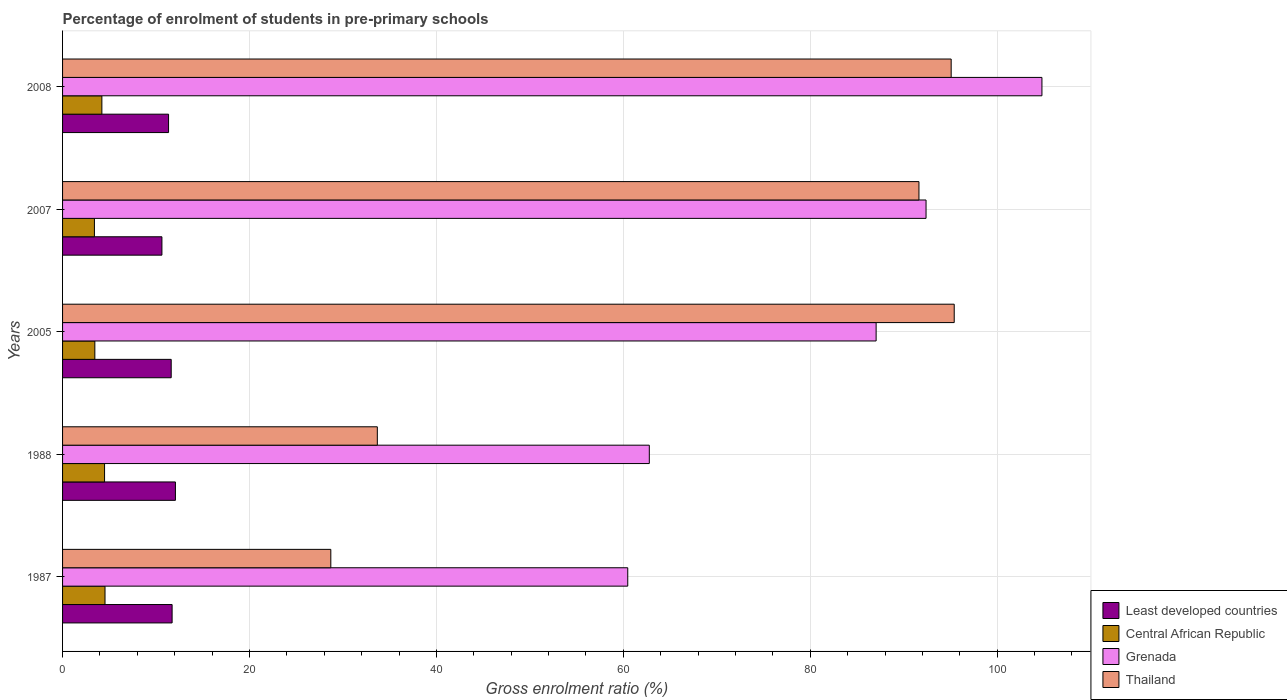How many different coloured bars are there?
Keep it short and to the point. 4. Are the number of bars on each tick of the Y-axis equal?
Offer a very short reply. Yes. How many bars are there on the 5th tick from the top?
Provide a succinct answer. 4. How many bars are there on the 1st tick from the bottom?
Keep it short and to the point. 4. What is the label of the 1st group of bars from the top?
Offer a very short reply. 2008. What is the percentage of students enrolled in pre-primary schools in Thailand in 2007?
Your answer should be compact. 91.63. Across all years, what is the maximum percentage of students enrolled in pre-primary schools in Thailand?
Provide a short and direct response. 95.4. Across all years, what is the minimum percentage of students enrolled in pre-primary schools in Thailand?
Make the answer very short. 28.7. In which year was the percentage of students enrolled in pre-primary schools in Thailand minimum?
Offer a very short reply. 1987. What is the total percentage of students enrolled in pre-primary schools in Thailand in the graph?
Offer a very short reply. 344.48. What is the difference between the percentage of students enrolled in pre-primary schools in Thailand in 1988 and that in 2005?
Offer a terse response. -61.73. What is the difference between the percentage of students enrolled in pre-primary schools in Thailand in 2005 and the percentage of students enrolled in pre-primary schools in Least developed countries in 2007?
Your answer should be very brief. 84.77. What is the average percentage of students enrolled in pre-primary schools in Central African Republic per year?
Your answer should be compact. 4.02. In the year 1987, what is the difference between the percentage of students enrolled in pre-primary schools in Grenada and percentage of students enrolled in pre-primary schools in Least developed countries?
Your answer should be very brief. 48.75. In how many years, is the percentage of students enrolled in pre-primary schools in Thailand greater than 88 %?
Ensure brevity in your answer.  3. What is the ratio of the percentage of students enrolled in pre-primary schools in Central African Republic in 1987 to that in 2005?
Keep it short and to the point. 1.32. Is the difference between the percentage of students enrolled in pre-primary schools in Grenada in 1987 and 2008 greater than the difference between the percentage of students enrolled in pre-primary schools in Least developed countries in 1987 and 2008?
Give a very brief answer. No. What is the difference between the highest and the second highest percentage of students enrolled in pre-primary schools in Central African Republic?
Keep it short and to the point. 0.05. What is the difference between the highest and the lowest percentage of students enrolled in pre-primary schools in Central African Republic?
Keep it short and to the point. 1.13. In how many years, is the percentage of students enrolled in pre-primary schools in Thailand greater than the average percentage of students enrolled in pre-primary schools in Thailand taken over all years?
Your answer should be very brief. 3. What does the 4th bar from the top in 1987 represents?
Provide a short and direct response. Least developed countries. What does the 2nd bar from the bottom in 1987 represents?
Give a very brief answer. Central African Republic. Is it the case that in every year, the sum of the percentage of students enrolled in pre-primary schools in Grenada and percentage of students enrolled in pre-primary schools in Central African Republic is greater than the percentage of students enrolled in pre-primary schools in Thailand?
Offer a terse response. No. What is the difference between two consecutive major ticks on the X-axis?
Your answer should be very brief. 20. Does the graph contain any zero values?
Offer a very short reply. No. How are the legend labels stacked?
Your answer should be compact. Vertical. What is the title of the graph?
Your answer should be very brief. Percentage of enrolment of students in pre-primary schools. Does "Vanuatu" appear as one of the legend labels in the graph?
Offer a very short reply. No. What is the Gross enrolment ratio (%) in Least developed countries in 1987?
Make the answer very short. 11.72. What is the Gross enrolment ratio (%) of Central African Republic in 1987?
Offer a terse response. 4.54. What is the Gross enrolment ratio (%) in Grenada in 1987?
Provide a succinct answer. 60.47. What is the Gross enrolment ratio (%) of Thailand in 1987?
Provide a short and direct response. 28.7. What is the Gross enrolment ratio (%) in Least developed countries in 1988?
Offer a terse response. 12.08. What is the Gross enrolment ratio (%) of Central African Republic in 1988?
Your response must be concise. 4.49. What is the Gross enrolment ratio (%) in Grenada in 1988?
Your response must be concise. 62.78. What is the Gross enrolment ratio (%) of Thailand in 1988?
Provide a short and direct response. 33.68. What is the Gross enrolment ratio (%) in Least developed countries in 2005?
Offer a terse response. 11.62. What is the Gross enrolment ratio (%) in Central African Republic in 2005?
Your response must be concise. 3.45. What is the Gross enrolment ratio (%) of Grenada in 2005?
Give a very brief answer. 87.05. What is the Gross enrolment ratio (%) of Thailand in 2005?
Offer a very short reply. 95.4. What is the Gross enrolment ratio (%) in Least developed countries in 2007?
Make the answer very short. 10.63. What is the Gross enrolment ratio (%) in Central African Republic in 2007?
Provide a succinct answer. 3.41. What is the Gross enrolment ratio (%) in Grenada in 2007?
Provide a short and direct response. 92.39. What is the Gross enrolment ratio (%) in Thailand in 2007?
Provide a succinct answer. 91.63. What is the Gross enrolment ratio (%) of Least developed countries in 2008?
Keep it short and to the point. 11.34. What is the Gross enrolment ratio (%) of Central African Republic in 2008?
Provide a short and direct response. 4.21. What is the Gross enrolment ratio (%) in Grenada in 2008?
Keep it short and to the point. 104.79. What is the Gross enrolment ratio (%) in Thailand in 2008?
Your answer should be very brief. 95.08. Across all years, what is the maximum Gross enrolment ratio (%) of Least developed countries?
Provide a short and direct response. 12.08. Across all years, what is the maximum Gross enrolment ratio (%) in Central African Republic?
Keep it short and to the point. 4.54. Across all years, what is the maximum Gross enrolment ratio (%) of Grenada?
Provide a succinct answer. 104.79. Across all years, what is the maximum Gross enrolment ratio (%) of Thailand?
Keep it short and to the point. 95.4. Across all years, what is the minimum Gross enrolment ratio (%) in Least developed countries?
Your response must be concise. 10.63. Across all years, what is the minimum Gross enrolment ratio (%) in Central African Republic?
Your answer should be very brief. 3.41. Across all years, what is the minimum Gross enrolment ratio (%) of Grenada?
Keep it short and to the point. 60.47. Across all years, what is the minimum Gross enrolment ratio (%) of Thailand?
Provide a succinct answer. 28.7. What is the total Gross enrolment ratio (%) in Least developed countries in the graph?
Provide a short and direct response. 57.39. What is the total Gross enrolment ratio (%) of Central African Republic in the graph?
Keep it short and to the point. 20.1. What is the total Gross enrolment ratio (%) of Grenada in the graph?
Your answer should be compact. 407.47. What is the total Gross enrolment ratio (%) in Thailand in the graph?
Provide a short and direct response. 344.48. What is the difference between the Gross enrolment ratio (%) of Least developed countries in 1987 and that in 1988?
Your response must be concise. -0.35. What is the difference between the Gross enrolment ratio (%) in Central African Republic in 1987 and that in 1988?
Your response must be concise. 0.05. What is the difference between the Gross enrolment ratio (%) of Grenada in 1987 and that in 1988?
Give a very brief answer. -2.31. What is the difference between the Gross enrolment ratio (%) of Thailand in 1987 and that in 1988?
Offer a terse response. -4.98. What is the difference between the Gross enrolment ratio (%) of Least developed countries in 1987 and that in 2005?
Give a very brief answer. 0.1. What is the difference between the Gross enrolment ratio (%) in Central African Republic in 1987 and that in 2005?
Offer a very short reply. 1.09. What is the difference between the Gross enrolment ratio (%) in Grenada in 1987 and that in 2005?
Provide a short and direct response. -26.57. What is the difference between the Gross enrolment ratio (%) of Thailand in 1987 and that in 2005?
Offer a very short reply. -66.7. What is the difference between the Gross enrolment ratio (%) in Least developed countries in 1987 and that in 2007?
Your response must be concise. 1.09. What is the difference between the Gross enrolment ratio (%) of Central African Republic in 1987 and that in 2007?
Keep it short and to the point. 1.13. What is the difference between the Gross enrolment ratio (%) in Grenada in 1987 and that in 2007?
Provide a succinct answer. -31.92. What is the difference between the Gross enrolment ratio (%) in Thailand in 1987 and that in 2007?
Your response must be concise. -62.93. What is the difference between the Gross enrolment ratio (%) of Least developed countries in 1987 and that in 2008?
Make the answer very short. 0.38. What is the difference between the Gross enrolment ratio (%) in Central African Republic in 1987 and that in 2008?
Ensure brevity in your answer.  0.34. What is the difference between the Gross enrolment ratio (%) of Grenada in 1987 and that in 2008?
Provide a succinct answer. -44.32. What is the difference between the Gross enrolment ratio (%) of Thailand in 1987 and that in 2008?
Make the answer very short. -66.38. What is the difference between the Gross enrolment ratio (%) of Least developed countries in 1988 and that in 2005?
Offer a terse response. 0.45. What is the difference between the Gross enrolment ratio (%) in Central African Republic in 1988 and that in 2005?
Your answer should be very brief. 1.04. What is the difference between the Gross enrolment ratio (%) in Grenada in 1988 and that in 2005?
Your response must be concise. -24.27. What is the difference between the Gross enrolment ratio (%) in Thailand in 1988 and that in 2005?
Your answer should be very brief. -61.73. What is the difference between the Gross enrolment ratio (%) of Least developed countries in 1988 and that in 2007?
Offer a terse response. 1.45. What is the difference between the Gross enrolment ratio (%) of Central African Republic in 1988 and that in 2007?
Give a very brief answer. 1.09. What is the difference between the Gross enrolment ratio (%) of Grenada in 1988 and that in 2007?
Provide a short and direct response. -29.61. What is the difference between the Gross enrolment ratio (%) in Thailand in 1988 and that in 2007?
Your response must be concise. -57.95. What is the difference between the Gross enrolment ratio (%) in Least developed countries in 1988 and that in 2008?
Keep it short and to the point. 0.73. What is the difference between the Gross enrolment ratio (%) in Central African Republic in 1988 and that in 2008?
Your answer should be compact. 0.29. What is the difference between the Gross enrolment ratio (%) of Grenada in 1988 and that in 2008?
Provide a short and direct response. -42.01. What is the difference between the Gross enrolment ratio (%) of Thailand in 1988 and that in 2008?
Give a very brief answer. -61.4. What is the difference between the Gross enrolment ratio (%) of Central African Republic in 2005 and that in 2007?
Offer a very short reply. 0.05. What is the difference between the Gross enrolment ratio (%) in Grenada in 2005 and that in 2007?
Your response must be concise. -5.34. What is the difference between the Gross enrolment ratio (%) of Thailand in 2005 and that in 2007?
Your answer should be compact. 3.77. What is the difference between the Gross enrolment ratio (%) of Least developed countries in 2005 and that in 2008?
Ensure brevity in your answer.  0.28. What is the difference between the Gross enrolment ratio (%) in Central African Republic in 2005 and that in 2008?
Provide a succinct answer. -0.75. What is the difference between the Gross enrolment ratio (%) of Grenada in 2005 and that in 2008?
Offer a terse response. -17.74. What is the difference between the Gross enrolment ratio (%) of Thailand in 2005 and that in 2008?
Ensure brevity in your answer.  0.33. What is the difference between the Gross enrolment ratio (%) in Least developed countries in 2007 and that in 2008?
Give a very brief answer. -0.71. What is the difference between the Gross enrolment ratio (%) in Central African Republic in 2007 and that in 2008?
Your answer should be compact. -0.8. What is the difference between the Gross enrolment ratio (%) of Grenada in 2007 and that in 2008?
Keep it short and to the point. -12.4. What is the difference between the Gross enrolment ratio (%) in Thailand in 2007 and that in 2008?
Offer a terse response. -3.45. What is the difference between the Gross enrolment ratio (%) in Least developed countries in 1987 and the Gross enrolment ratio (%) in Central African Republic in 1988?
Give a very brief answer. 7.23. What is the difference between the Gross enrolment ratio (%) of Least developed countries in 1987 and the Gross enrolment ratio (%) of Grenada in 1988?
Offer a very short reply. -51.06. What is the difference between the Gross enrolment ratio (%) of Least developed countries in 1987 and the Gross enrolment ratio (%) of Thailand in 1988?
Your response must be concise. -21.96. What is the difference between the Gross enrolment ratio (%) of Central African Republic in 1987 and the Gross enrolment ratio (%) of Grenada in 1988?
Ensure brevity in your answer.  -58.24. What is the difference between the Gross enrolment ratio (%) of Central African Republic in 1987 and the Gross enrolment ratio (%) of Thailand in 1988?
Make the answer very short. -29.13. What is the difference between the Gross enrolment ratio (%) of Grenada in 1987 and the Gross enrolment ratio (%) of Thailand in 1988?
Offer a terse response. 26.79. What is the difference between the Gross enrolment ratio (%) in Least developed countries in 1987 and the Gross enrolment ratio (%) in Central African Republic in 2005?
Give a very brief answer. 8.27. What is the difference between the Gross enrolment ratio (%) in Least developed countries in 1987 and the Gross enrolment ratio (%) in Grenada in 2005?
Your response must be concise. -75.32. What is the difference between the Gross enrolment ratio (%) in Least developed countries in 1987 and the Gross enrolment ratio (%) in Thailand in 2005?
Provide a short and direct response. -83.68. What is the difference between the Gross enrolment ratio (%) in Central African Republic in 1987 and the Gross enrolment ratio (%) in Grenada in 2005?
Ensure brevity in your answer.  -82.5. What is the difference between the Gross enrolment ratio (%) of Central African Republic in 1987 and the Gross enrolment ratio (%) of Thailand in 2005?
Offer a very short reply. -90.86. What is the difference between the Gross enrolment ratio (%) in Grenada in 1987 and the Gross enrolment ratio (%) in Thailand in 2005?
Offer a very short reply. -34.93. What is the difference between the Gross enrolment ratio (%) in Least developed countries in 1987 and the Gross enrolment ratio (%) in Central African Republic in 2007?
Give a very brief answer. 8.31. What is the difference between the Gross enrolment ratio (%) of Least developed countries in 1987 and the Gross enrolment ratio (%) of Grenada in 2007?
Make the answer very short. -80.67. What is the difference between the Gross enrolment ratio (%) in Least developed countries in 1987 and the Gross enrolment ratio (%) in Thailand in 2007?
Offer a terse response. -79.91. What is the difference between the Gross enrolment ratio (%) of Central African Republic in 1987 and the Gross enrolment ratio (%) of Grenada in 2007?
Give a very brief answer. -87.85. What is the difference between the Gross enrolment ratio (%) of Central African Republic in 1987 and the Gross enrolment ratio (%) of Thailand in 2007?
Ensure brevity in your answer.  -87.09. What is the difference between the Gross enrolment ratio (%) in Grenada in 1987 and the Gross enrolment ratio (%) in Thailand in 2007?
Give a very brief answer. -31.16. What is the difference between the Gross enrolment ratio (%) in Least developed countries in 1987 and the Gross enrolment ratio (%) in Central African Republic in 2008?
Your answer should be very brief. 7.52. What is the difference between the Gross enrolment ratio (%) in Least developed countries in 1987 and the Gross enrolment ratio (%) in Grenada in 2008?
Your answer should be compact. -93.07. What is the difference between the Gross enrolment ratio (%) of Least developed countries in 1987 and the Gross enrolment ratio (%) of Thailand in 2008?
Provide a succinct answer. -83.35. What is the difference between the Gross enrolment ratio (%) of Central African Republic in 1987 and the Gross enrolment ratio (%) of Grenada in 2008?
Offer a very short reply. -100.25. What is the difference between the Gross enrolment ratio (%) in Central African Republic in 1987 and the Gross enrolment ratio (%) in Thailand in 2008?
Ensure brevity in your answer.  -90.53. What is the difference between the Gross enrolment ratio (%) of Grenada in 1987 and the Gross enrolment ratio (%) of Thailand in 2008?
Your answer should be compact. -34.6. What is the difference between the Gross enrolment ratio (%) in Least developed countries in 1988 and the Gross enrolment ratio (%) in Central African Republic in 2005?
Give a very brief answer. 8.62. What is the difference between the Gross enrolment ratio (%) in Least developed countries in 1988 and the Gross enrolment ratio (%) in Grenada in 2005?
Provide a succinct answer. -74.97. What is the difference between the Gross enrolment ratio (%) in Least developed countries in 1988 and the Gross enrolment ratio (%) in Thailand in 2005?
Make the answer very short. -83.33. What is the difference between the Gross enrolment ratio (%) of Central African Republic in 1988 and the Gross enrolment ratio (%) of Grenada in 2005?
Your answer should be very brief. -82.55. What is the difference between the Gross enrolment ratio (%) of Central African Republic in 1988 and the Gross enrolment ratio (%) of Thailand in 2005?
Keep it short and to the point. -90.91. What is the difference between the Gross enrolment ratio (%) in Grenada in 1988 and the Gross enrolment ratio (%) in Thailand in 2005?
Keep it short and to the point. -32.62. What is the difference between the Gross enrolment ratio (%) of Least developed countries in 1988 and the Gross enrolment ratio (%) of Central African Republic in 2007?
Make the answer very short. 8.67. What is the difference between the Gross enrolment ratio (%) of Least developed countries in 1988 and the Gross enrolment ratio (%) of Grenada in 2007?
Give a very brief answer. -80.31. What is the difference between the Gross enrolment ratio (%) of Least developed countries in 1988 and the Gross enrolment ratio (%) of Thailand in 2007?
Make the answer very short. -79.55. What is the difference between the Gross enrolment ratio (%) of Central African Republic in 1988 and the Gross enrolment ratio (%) of Grenada in 2007?
Offer a very short reply. -87.89. What is the difference between the Gross enrolment ratio (%) of Central African Republic in 1988 and the Gross enrolment ratio (%) of Thailand in 2007?
Make the answer very short. -87.13. What is the difference between the Gross enrolment ratio (%) of Grenada in 1988 and the Gross enrolment ratio (%) of Thailand in 2007?
Give a very brief answer. -28.85. What is the difference between the Gross enrolment ratio (%) in Least developed countries in 1988 and the Gross enrolment ratio (%) in Central African Republic in 2008?
Ensure brevity in your answer.  7.87. What is the difference between the Gross enrolment ratio (%) in Least developed countries in 1988 and the Gross enrolment ratio (%) in Grenada in 2008?
Make the answer very short. -92.71. What is the difference between the Gross enrolment ratio (%) of Least developed countries in 1988 and the Gross enrolment ratio (%) of Thailand in 2008?
Offer a terse response. -83. What is the difference between the Gross enrolment ratio (%) of Central African Republic in 1988 and the Gross enrolment ratio (%) of Grenada in 2008?
Your answer should be very brief. -100.29. What is the difference between the Gross enrolment ratio (%) of Central African Republic in 1988 and the Gross enrolment ratio (%) of Thailand in 2008?
Give a very brief answer. -90.58. What is the difference between the Gross enrolment ratio (%) of Grenada in 1988 and the Gross enrolment ratio (%) of Thailand in 2008?
Make the answer very short. -32.3. What is the difference between the Gross enrolment ratio (%) in Least developed countries in 2005 and the Gross enrolment ratio (%) in Central African Republic in 2007?
Keep it short and to the point. 8.21. What is the difference between the Gross enrolment ratio (%) of Least developed countries in 2005 and the Gross enrolment ratio (%) of Grenada in 2007?
Your response must be concise. -80.77. What is the difference between the Gross enrolment ratio (%) of Least developed countries in 2005 and the Gross enrolment ratio (%) of Thailand in 2007?
Offer a very short reply. -80.01. What is the difference between the Gross enrolment ratio (%) in Central African Republic in 2005 and the Gross enrolment ratio (%) in Grenada in 2007?
Your response must be concise. -88.93. What is the difference between the Gross enrolment ratio (%) of Central African Republic in 2005 and the Gross enrolment ratio (%) of Thailand in 2007?
Offer a very short reply. -88.17. What is the difference between the Gross enrolment ratio (%) of Grenada in 2005 and the Gross enrolment ratio (%) of Thailand in 2007?
Offer a very short reply. -4.58. What is the difference between the Gross enrolment ratio (%) in Least developed countries in 2005 and the Gross enrolment ratio (%) in Central African Republic in 2008?
Provide a succinct answer. 7.42. What is the difference between the Gross enrolment ratio (%) of Least developed countries in 2005 and the Gross enrolment ratio (%) of Grenada in 2008?
Your response must be concise. -93.17. What is the difference between the Gross enrolment ratio (%) of Least developed countries in 2005 and the Gross enrolment ratio (%) of Thailand in 2008?
Give a very brief answer. -83.45. What is the difference between the Gross enrolment ratio (%) in Central African Republic in 2005 and the Gross enrolment ratio (%) in Grenada in 2008?
Provide a short and direct response. -101.33. What is the difference between the Gross enrolment ratio (%) in Central African Republic in 2005 and the Gross enrolment ratio (%) in Thailand in 2008?
Your response must be concise. -91.62. What is the difference between the Gross enrolment ratio (%) in Grenada in 2005 and the Gross enrolment ratio (%) in Thailand in 2008?
Your response must be concise. -8.03. What is the difference between the Gross enrolment ratio (%) in Least developed countries in 2007 and the Gross enrolment ratio (%) in Central African Republic in 2008?
Your response must be concise. 6.42. What is the difference between the Gross enrolment ratio (%) of Least developed countries in 2007 and the Gross enrolment ratio (%) of Grenada in 2008?
Provide a short and direct response. -94.16. What is the difference between the Gross enrolment ratio (%) in Least developed countries in 2007 and the Gross enrolment ratio (%) in Thailand in 2008?
Keep it short and to the point. -84.45. What is the difference between the Gross enrolment ratio (%) of Central African Republic in 2007 and the Gross enrolment ratio (%) of Grenada in 2008?
Your response must be concise. -101.38. What is the difference between the Gross enrolment ratio (%) of Central African Republic in 2007 and the Gross enrolment ratio (%) of Thailand in 2008?
Your answer should be compact. -91.67. What is the difference between the Gross enrolment ratio (%) of Grenada in 2007 and the Gross enrolment ratio (%) of Thailand in 2008?
Your answer should be very brief. -2.69. What is the average Gross enrolment ratio (%) in Least developed countries per year?
Keep it short and to the point. 11.48. What is the average Gross enrolment ratio (%) in Central African Republic per year?
Give a very brief answer. 4.02. What is the average Gross enrolment ratio (%) of Grenada per year?
Make the answer very short. 81.49. What is the average Gross enrolment ratio (%) of Thailand per year?
Offer a terse response. 68.9. In the year 1987, what is the difference between the Gross enrolment ratio (%) in Least developed countries and Gross enrolment ratio (%) in Central African Republic?
Offer a terse response. 7.18. In the year 1987, what is the difference between the Gross enrolment ratio (%) of Least developed countries and Gross enrolment ratio (%) of Grenada?
Offer a very short reply. -48.75. In the year 1987, what is the difference between the Gross enrolment ratio (%) in Least developed countries and Gross enrolment ratio (%) in Thailand?
Provide a short and direct response. -16.98. In the year 1987, what is the difference between the Gross enrolment ratio (%) of Central African Republic and Gross enrolment ratio (%) of Grenada?
Give a very brief answer. -55.93. In the year 1987, what is the difference between the Gross enrolment ratio (%) in Central African Republic and Gross enrolment ratio (%) in Thailand?
Make the answer very short. -24.16. In the year 1987, what is the difference between the Gross enrolment ratio (%) of Grenada and Gross enrolment ratio (%) of Thailand?
Provide a short and direct response. 31.77. In the year 1988, what is the difference between the Gross enrolment ratio (%) of Least developed countries and Gross enrolment ratio (%) of Central African Republic?
Your answer should be very brief. 7.58. In the year 1988, what is the difference between the Gross enrolment ratio (%) in Least developed countries and Gross enrolment ratio (%) in Grenada?
Provide a short and direct response. -50.7. In the year 1988, what is the difference between the Gross enrolment ratio (%) of Least developed countries and Gross enrolment ratio (%) of Thailand?
Your response must be concise. -21.6. In the year 1988, what is the difference between the Gross enrolment ratio (%) in Central African Republic and Gross enrolment ratio (%) in Grenada?
Your answer should be compact. -58.28. In the year 1988, what is the difference between the Gross enrolment ratio (%) of Central African Republic and Gross enrolment ratio (%) of Thailand?
Provide a short and direct response. -29.18. In the year 1988, what is the difference between the Gross enrolment ratio (%) of Grenada and Gross enrolment ratio (%) of Thailand?
Keep it short and to the point. 29.1. In the year 2005, what is the difference between the Gross enrolment ratio (%) in Least developed countries and Gross enrolment ratio (%) in Central African Republic?
Your answer should be very brief. 8.17. In the year 2005, what is the difference between the Gross enrolment ratio (%) in Least developed countries and Gross enrolment ratio (%) in Grenada?
Ensure brevity in your answer.  -75.42. In the year 2005, what is the difference between the Gross enrolment ratio (%) of Least developed countries and Gross enrolment ratio (%) of Thailand?
Make the answer very short. -83.78. In the year 2005, what is the difference between the Gross enrolment ratio (%) of Central African Republic and Gross enrolment ratio (%) of Grenada?
Give a very brief answer. -83.59. In the year 2005, what is the difference between the Gross enrolment ratio (%) of Central African Republic and Gross enrolment ratio (%) of Thailand?
Provide a short and direct response. -91.95. In the year 2005, what is the difference between the Gross enrolment ratio (%) in Grenada and Gross enrolment ratio (%) in Thailand?
Keep it short and to the point. -8.36. In the year 2007, what is the difference between the Gross enrolment ratio (%) of Least developed countries and Gross enrolment ratio (%) of Central African Republic?
Offer a terse response. 7.22. In the year 2007, what is the difference between the Gross enrolment ratio (%) in Least developed countries and Gross enrolment ratio (%) in Grenada?
Make the answer very short. -81.76. In the year 2007, what is the difference between the Gross enrolment ratio (%) of Least developed countries and Gross enrolment ratio (%) of Thailand?
Your response must be concise. -81. In the year 2007, what is the difference between the Gross enrolment ratio (%) of Central African Republic and Gross enrolment ratio (%) of Grenada?
Keep it short and to the point. -88.98. In the year 2007, what is the difference between the Gross enrolment ratio (%) of Central African Republic and Gross enrolment ratio (%) of Thailand?
Offer a very short reply. -88.22. In the year 2007, what is the difference between the Gross enrolment ratio (%) in Grenada and Gross enrolment ratio (%) in Thailand?
Offer a terse response. 0.76. In the year 2008, what is the difference between the Gross enrolment ratio (%) in Least developed countries and Gross enrolment ratio (%) in Central African Republic?
Make the answer very short. 7.14. In the year 2008, what is the difference between the Gross enrolment ratio (%) of Least developed countries and Gross enrolment ratio (%) of Grenada?
Keep it short and to the point. -93.45. In the year 2008, what is the difference between the Gross enrolment ratio (%) in Least developed countries and Gross enrolment ratio (%) in Thailand?
Your response must be concise. -83.73. In the year 2008, what is the difference between the Gross enrolment ratio (%) in Central African Republic and Gross enrolment ratio (%) in Grenada?
Make the answer very short. -100.58. In the year 2008, what is the difference between the Gross enrolment ratio (%) in Central African Republic and Gross enrolment ratio (%) in Thailand?
Your response must be concise. -90.87. In the year 2008, what is the difference between the Gross enrolment ratio (%) of Grenada and Gross enrolment ratio (%) of Thailand?
Give a very brief answer. 9.71. What is the ratio of the Gross enrolment ratio (%) of Least developed countries in 1987 to that in 1988?
Provide a succinct answer. 0.97. What is the ratio of the Gross enrolment ratio (%) of Central African Republic in 1987 to that in 1988?
Your response must be concise. 1.01. What is the ratio of the Gross enrolment ratio (%) in Grenada in 1987 to that in 1988?
Offer a very short reply. 0.96. What is the ratio of the Gross enrolment ratio (%) of Thailand in 1987 to that in 1988?
Offer a terse response. 0.85. What is the ratio of the Gross enrolment ratio (%) in Least developed countries in 1987 to that in 2005?
Your response must be concise. 1.01. What is the ratio of the Gross enrolment ratio (%) in Central African Republic in 1987 to that in 2005?
Make the answer very short. 1.32. What is the ratio of the Gross enrolment ratio (%) in Grenada in 1987 to that in 2005?
Offer a terse response. 0.69. What is the ratio of the Gross enrolment ratio (%) in Thailand in 1987 to that in 2005?
Keep it short and to the point. 0.3. What is the ratio of the Gross enrolment ratio (%) in Least developed countries in 1987 to that in 2007?
Provide a short and direct response. 1.1. What is the ratio of the Gross enrolment ratio (%) of Central African Republic in 1987 to that in 2007?
Offer a very short reply. 1.33. What is the ratio of the Gross enrolment ratio (%) of Grenada in 1987 to that in 2007?
Provide a short and direct response. 0.65. What is the ratio of the Gross enrolment ratio (%) of Thailand in 1987 to that in 2007?
Provide a short and direct response. 0.31. What is the ratio of the Gross enrolment ratio (%) of Least developed countries in 1987 to that in 2008?
Your answer should be very brief. 1.03. What is the ratio of the Gross enrolment ratio (%) in Central African Republic in 1987 to that in 2008?
Offer a very short reply. 1.08. What is the ratio of the Gross enrolment ratio (%) of Grenada in 1987 to that in 2008?
Offer a terse response. 0.58. What is the ratio of the Gross enrolment ratio (%) of Thailand in 1987 to that in 2008?
Keep it short and to the point. 0.3. What is the ratio of the Gross enrolment ratio (%) in Least developed countries in 1988 to that in 2005?
Offer a terse response. 1.04. What is the ratio of the Gross enrolment ratio (%) of Central African Republic in 1988 to that in 2005?
Your answer should be very brief. 1.3. What is the ratio of the Gross enrolment ratio (%) in Grenada in 1988 to that in 2005?
Offer a terse response. 0.72. What is the ratio of the Gross enrolment ratio (%) of Thailand in 1988 to that in 2005?
Keep it short and to the point. 0.35. What is the ratio of the Gross enrolment ratio (%) of Least developed countries in 1988 to that in 2007?
Keep it short and to the point. 1.14. What is the ratio of the Gross enrolment ratio (%) in Central African Republic in 1988 to that in 2007?
Offer a very short reply. 1.32. What is the ratio of the Gross enrolment ratio (%) in Grenada in 1988 to that in 2007?
Give a very brief answer. 0.68. What is the ratio of the Gross enrolment ratio (%) of Thailand in 1988 to that in 2007?
Make the answer very short. 0.37. What is the ratio of the Gross enrolment ratio (%) in Least developed countries in 1988 to that in 2008?
Give a very brief answer. 1.06. What is the ratio of the Gross enrolment ratio (%) in Central African Republic in 1988 to that in 2008?
Keep it short and to the point. 1.07. What is the ratio of the Gross enrolment ratio (%) of Grenada in 1988 to that in 2008?
Offer a very short reply. 0.6. What is the ratio of the Gross enrolment ratio (%) in Thailand in 1988 to that in 2008?
Your answer should be very brief. 0.35. What is the ratio of the Gross enrolment ratio (%) in Least developed countries in 2005 to that in 2007?
Provide a succinct answer. 1.09. What is the ratio of the Gross enrolment ratio (%) of Central African Republic in 2005 to that in 2007?
Make the answer very short. 1.01. What is the ratio of the Gross enrolment ratio (%) of Grenada in 2005 to that in 2007?
Your answer should be compact. 0.94. What is the ratio of the Gross enrolment ratio (%) in Thailand in 2005 to that in 2007?
Keep it short and to the point. 1.04. What is the ratio of the Gross enrolment ratio (%) in Least developed countries in 2005 to that in 2008?
Your answer should be very brief. 1.02. What is the ratio of the Gross enrolment ratio (%) of Central African Republic in 2005 to that in 2008?
Your response must be concise. 0.82. What is the ratio of the Gross enrolment ratio (%) of Grenada in 2005 to that in 2008?
Provide a short and direct response. 0.83. What is the ratio of the Gross enrolment ratio (%) of Thailand in 2005 to that in 2008?
Provide a short and direct response. 1. What is the ratio of the Gross enrolment ratio (%) in Least developed countries in 2007 to that in 2008?
Your answer should be very brief. 0.94. What is the ratio of the Gross enrolment ratio (%) of Central African Republic in 2007 to that in 2008?
Provide a short and direct response. 0.81. What is the ratio of the Gross enrolment ratio (%) in Grenada in 2007 to that in 2008?
Your answer should be very brief. 0.88. What is the ratio of the Gross enrolment ratio (%) in Thailand in 2007 to that in 2008?
Your answer should be compact. 0.96. What is the difference between the highest and the second highest Gross enrolment ratio (%) in Least developed countries?
Your answer should be very brief. 0.35. What is the difference between the highest and the second highest Gross enrolment ratio (%) in Central African Republic?
Your response must be concise. 0.05. What is the difference between the highest and the second highest Gross enrolment ratio (%) in Grenada?
Keep it short and to the point. 12.4. What is the difference between the highest and the second highest Gross enrolment ratio (%) of Thailand?
Give a very brief answer. 0.33. What is the difference between the highest and the lowest Gross enrolment ratio (%) in Least developed countries?
Your response must be concise. 1.45. What is the difference between the highest and the lowest Gross enrolment ratio (%) of Central African Republic?
Make the answer very short. 1.13. What is the difference between the highest and the lowest Gross enrolment ratio (%) in Grenada?
Make the answer very short. 44.32. What is the difference between the highest and the lowest Gross enrolment ratio (%) in Thailand?
Provide a short and direct response. 66.7. 